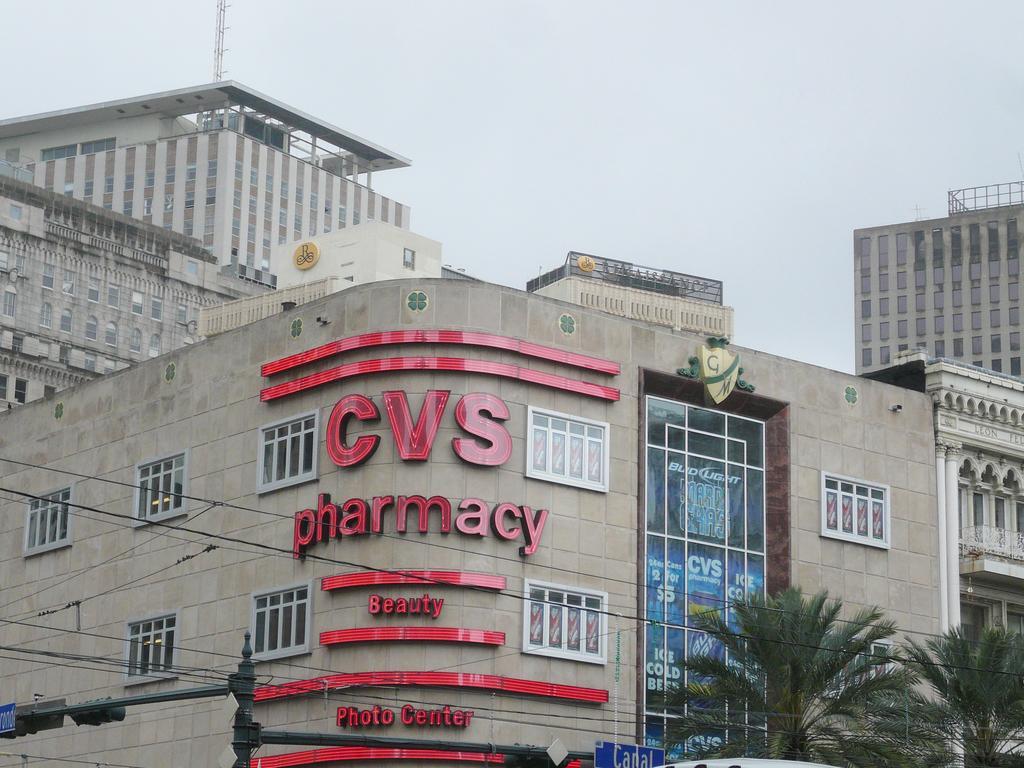Describe this image in one or two sentences. In this image I can see buildings. There are trees and wires in the front. There is sky at the top. 